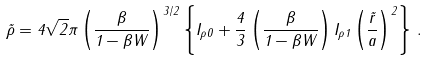Convert formula to latex. <formula><loc_0><loc_0><loc_500><loc_500>\tilde { \rho } = 4 \sqrt { 2 } \pi \left ( \frac { \beta } { 1 - \beta W } \right ) ^ { 3 / 2 } \left \{ I _ { \rho 0 } + \frac { 4 } { 3 } \left ( \frac { \beta } { 1 - \beta W } \right ) I _ { \rho 1 } \left ( \frac { \tilde { r } } { a } \right ) ^ { 2 } \right \} \, .</formula> 